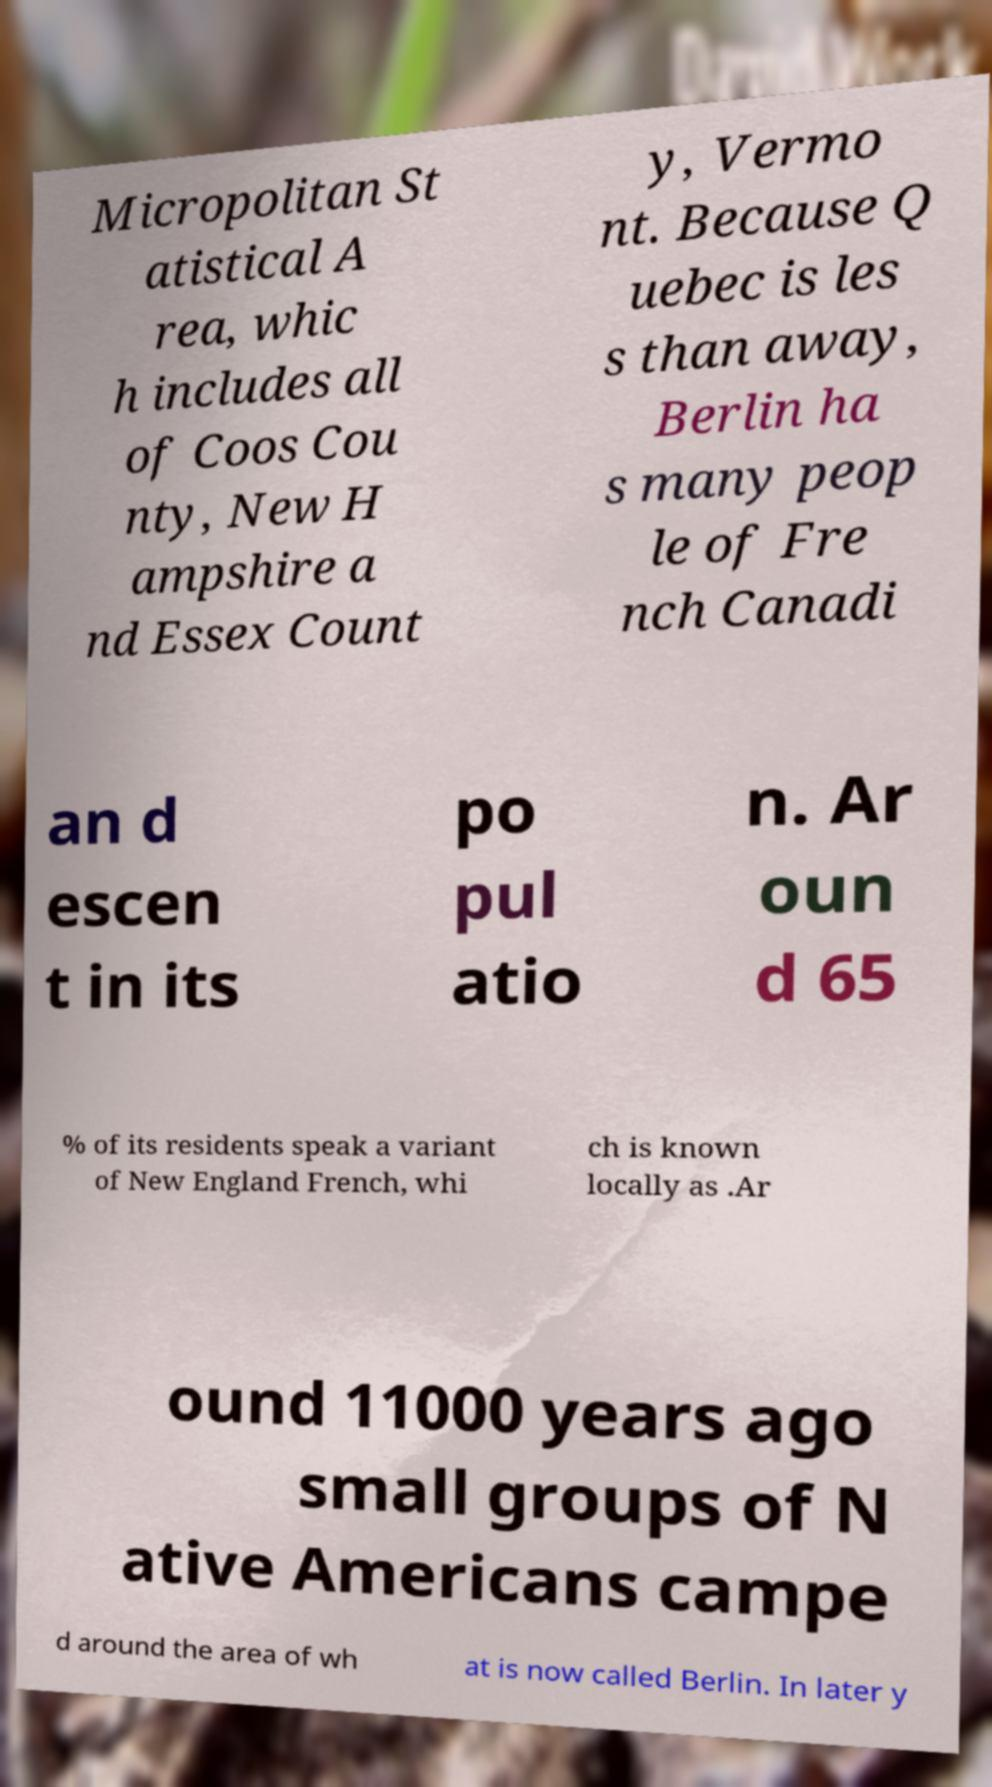Could you extract and type out the text from this image? Micropolitan St atistical A rea, whic h includes all of Coos Cou nty, New H ampshire a nd Essex Count y, Vermo nt. Because Q uebec is les s than away, Berlin ha s many peop le of Fre nch Canadi an d escen t in its po pul atio n. Ar oun d 65 % of its residents speak a variant of New England French, whi ch is known locally as .Ar ound 11000 years ago small groups of N ative Americans campe d around the area of wh at is now called Berlin. In later y 